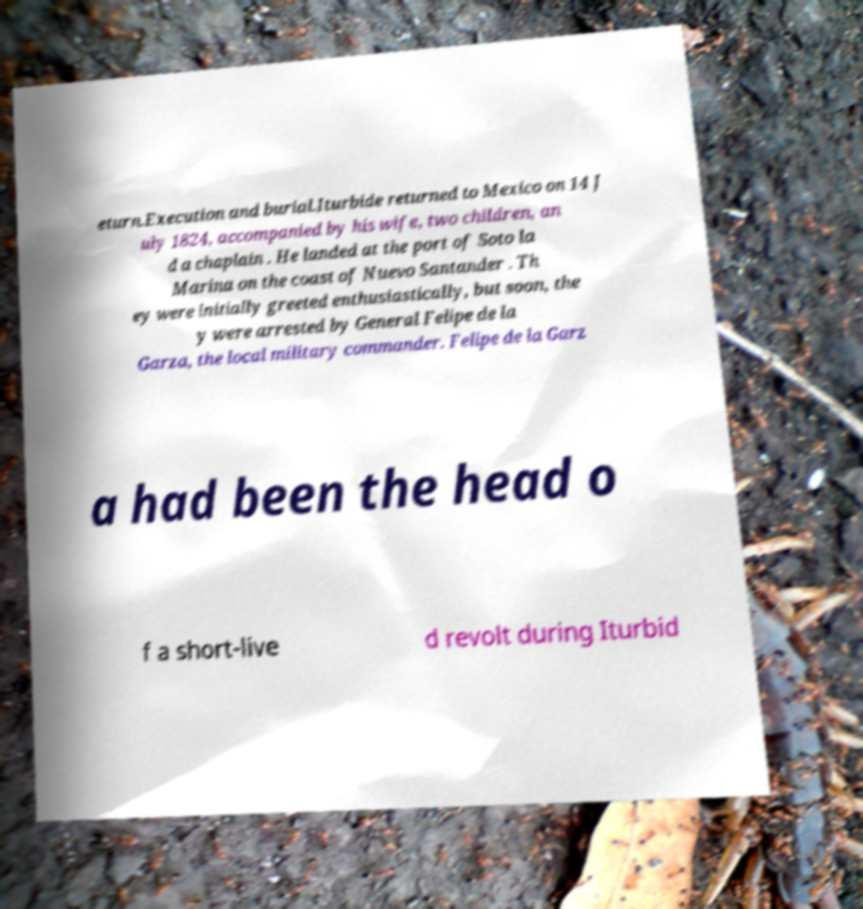I need the written content from this picture converted into text. Can you do that? eturn.Execution and burial.Iturbide returned to Mexico on 14 J uly 1824, accompanied by his wife, two children, an d a chaplain . He landed at the port of Soto la Marina on the coast of Nuevo Santander . Th ey were initially greeted enthusiastically, but soon, the y were arrested by General Felipe de la Garza, the local military commander. Felipe de la Garz a had been the head o f a short-live d revolt during Iturbid 